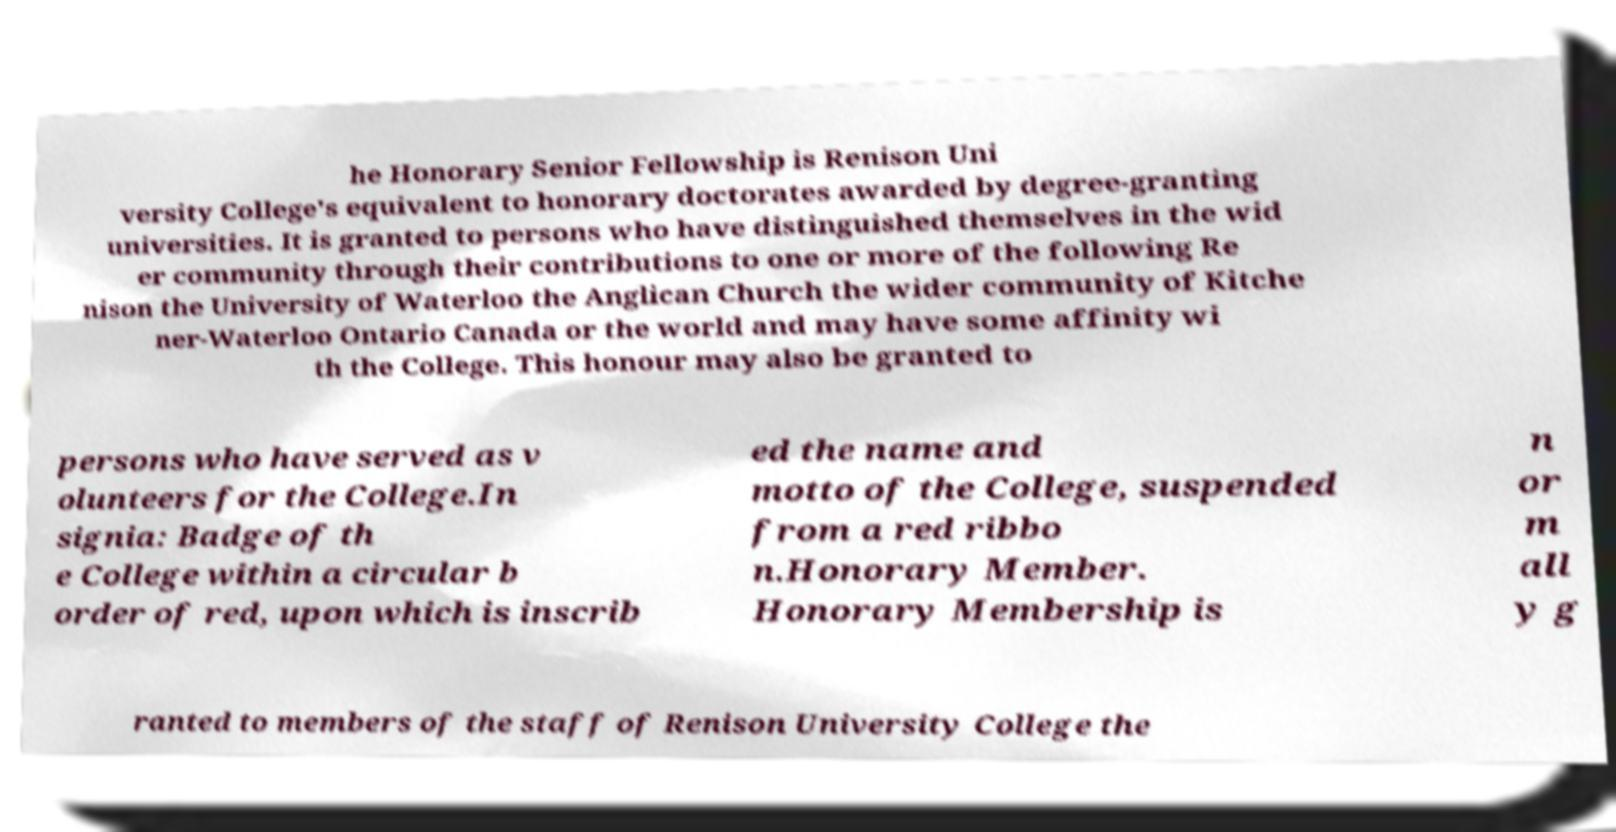I need the written content from this picture converted into text. Can you do that? he Honorary Senior Fellowship is Renison Uni versity College's equivalent to honorary doctorates awarded by degree-granting universities. It is granted to persons who have distinguished themselves in the wid er community through their contributions to one or more of the following Re nison the University of Waterloo the Anglican Church the wider community of Kitche ner-Waterloo Ontario Canada or the world and may have some affinity wi th the College. This honour may also be granted to persons who have served as v olunteers for the College.In signia: Badge of th e College within a circular b order of red, upon which is inscrib ed the name and motto of the College, suspended from a red ribbo n.Honorary Member. Honorary Membership is n or m all y g ranted to members of the staff of Renison University College the 